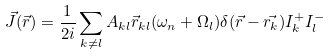Convert formula to latex. <formula><loc_0><loc_0><loc_500><loc_500>\vec { J } ( \vec { r } ) = \frac { 1 } { 2 i } \sum _ { k \neq l } A _ { k l } \vec { r } _ { k l } ( \omega _ { n } + \Omega _ { l } ) \delta ( \vec { r } - \vec { r _ { k } } ) I _ { k } ^ { + } I _ { l } ^ { - }</formula> 